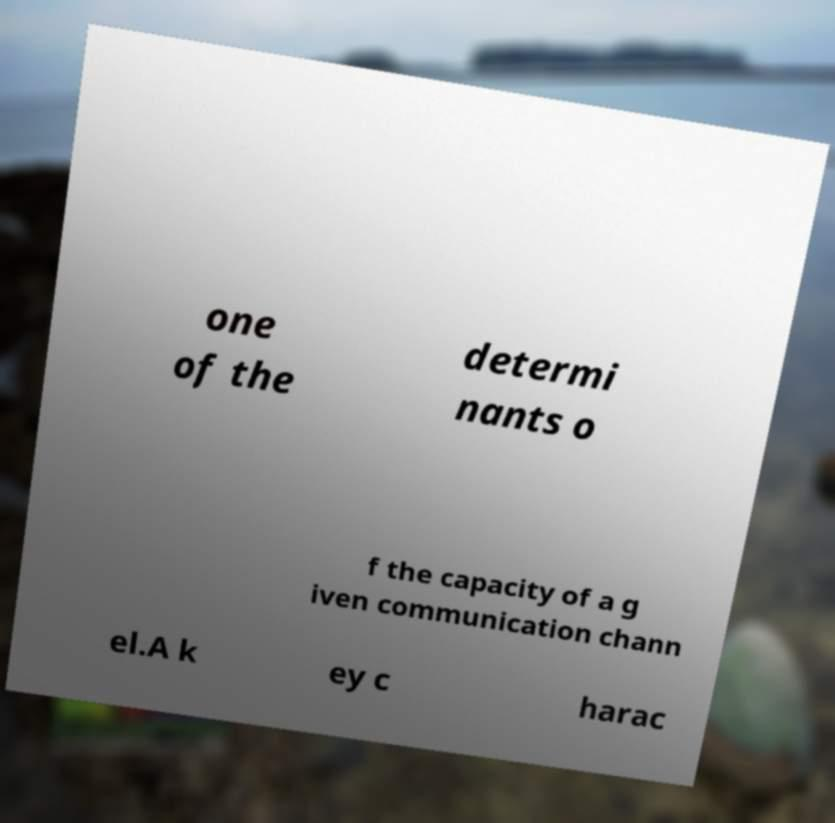Can you read and provide the text displayed in the image?This photo seems to have some interesting text. Can you extract and type it out for me? one of the determi nants o f the capacity of a g iven communication chann el.A k ey c harac 